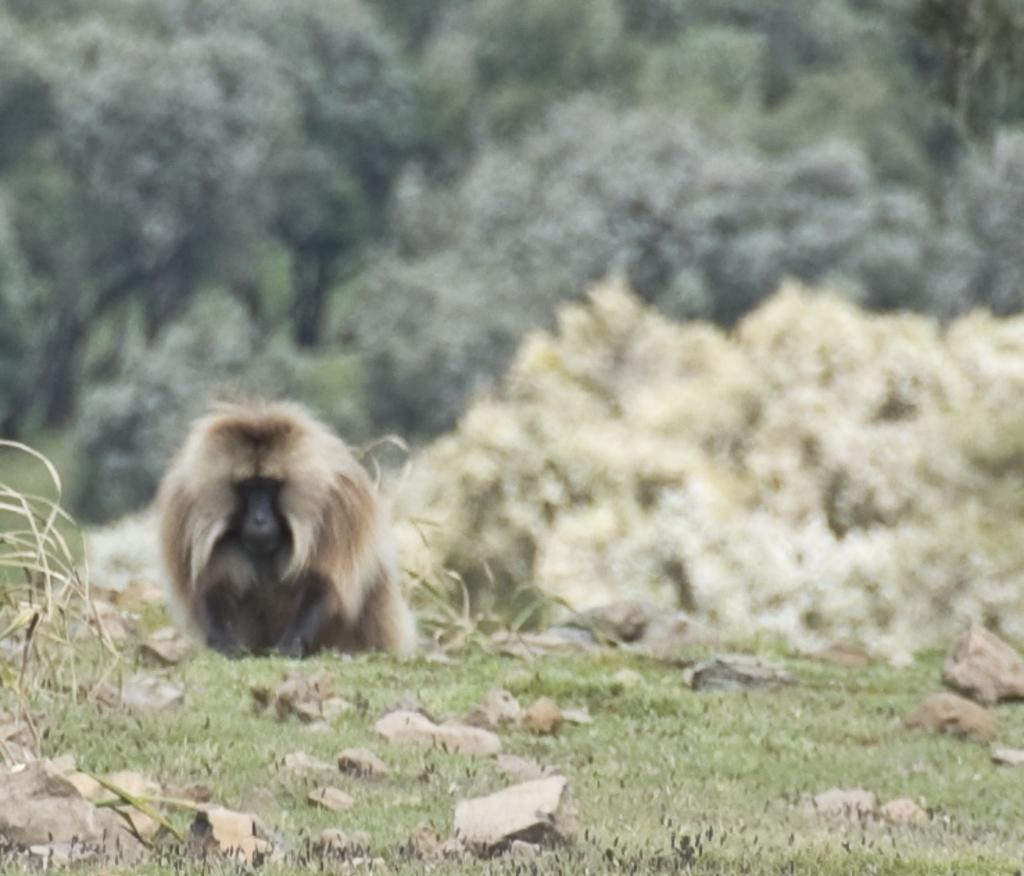What type of creature is in the image? There is an animal in the image, and it looks like a monkey. What is the ground surface like in the image? The ground has grass in the image. How would you describe the background of the image? The background of the image is blurred. How many toes does the monkey have in the image? The image does not show the monkey's toes, so it cannot be determined from the image. 